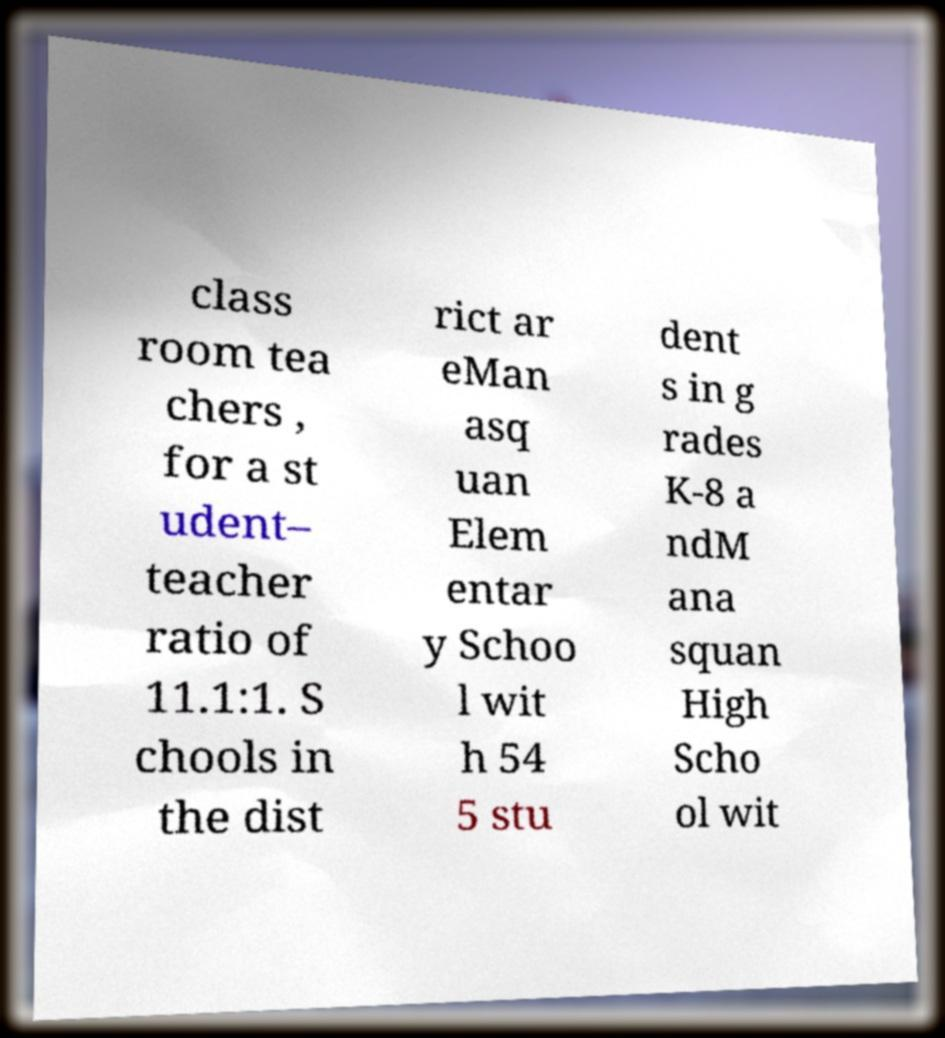Please identify and transcribe the text found in this image. class room tea chers , for a st udent– teacher ratio of 11.1:1. S chools in the dist rict ar eMan asq uan Elem entar y Schoo l wit h 54 5 stu dent s in g rades K-8 a ndM ana squan High Scho ol wit 